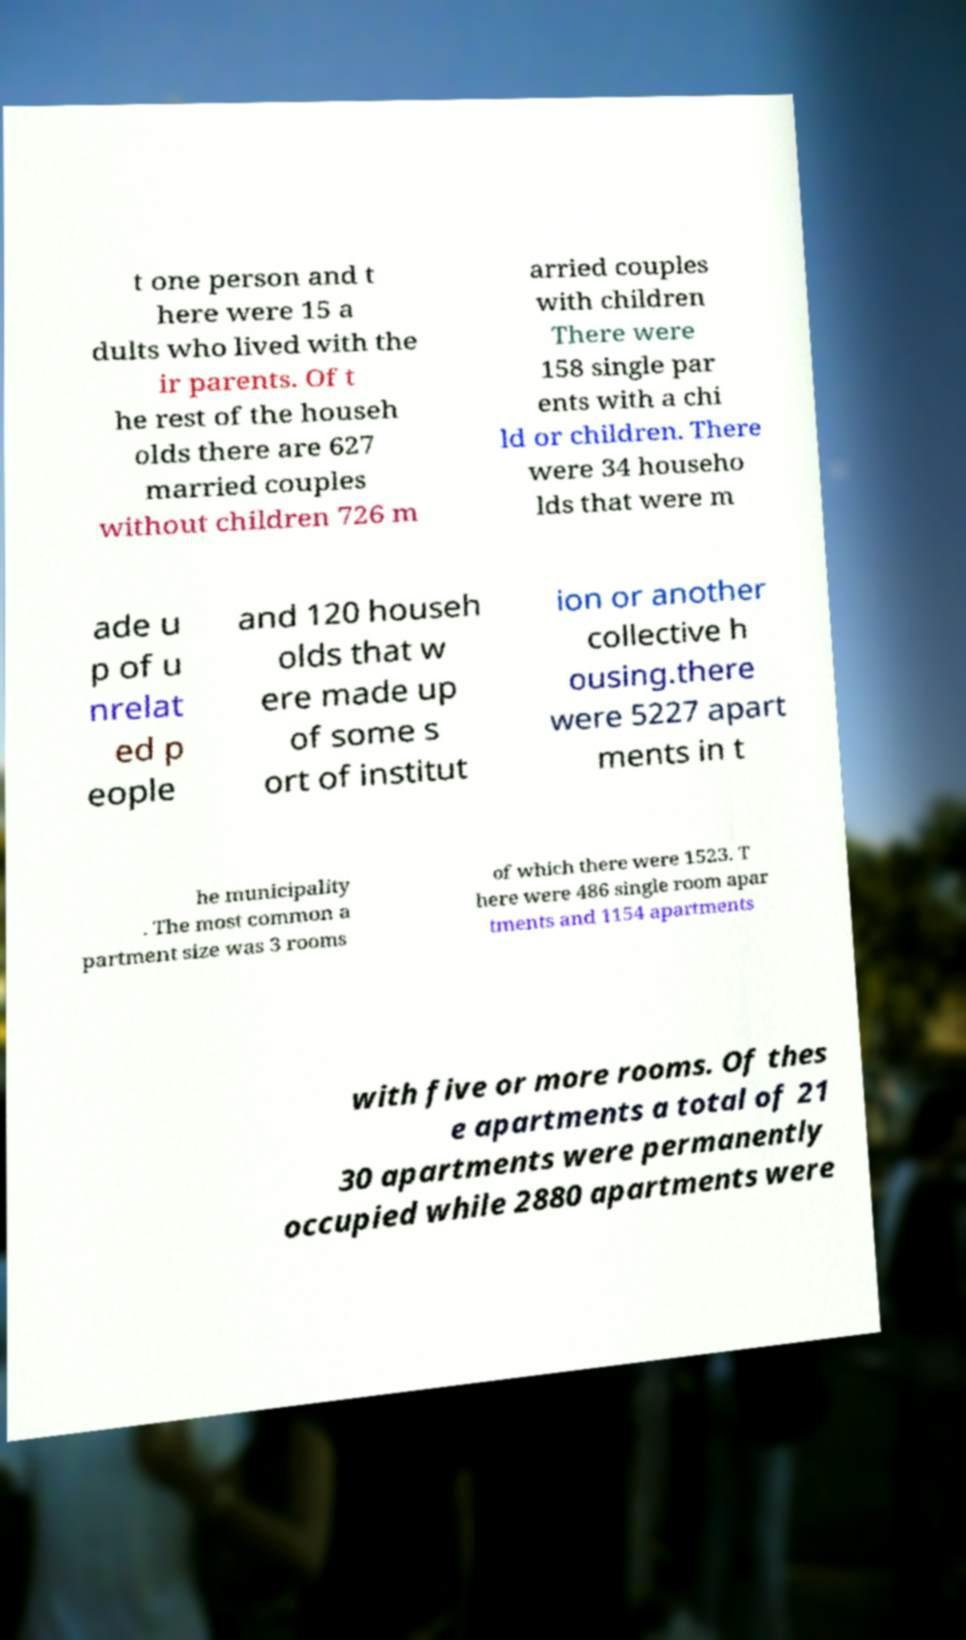Can you read and provide the text displayed in the image?This photo seems to have some interesting text. Can you extract and type it out for me? t one person and t here were 15 a dults who lived with the ir parents. Of t he rest of the househ olds there are 627 married couples without children 726 m arried couples with children There were 158 single par ents with a chi ld or children. There were 34 househo lds that were m ade u p of u nrelat ed p eople and 120 househ olds that w ere made up of some s ort of institut ion or another collective h ousing.there were 5227 apart ments in t he municipality . The most common a partment size was 3 rooms of which there were 1523. T here were 486 single room apar tments and 1154 apartments with five or more rooms. Of thes e apartments a total of 21 30 apartments were permanently occupied while 2880 apartments were 